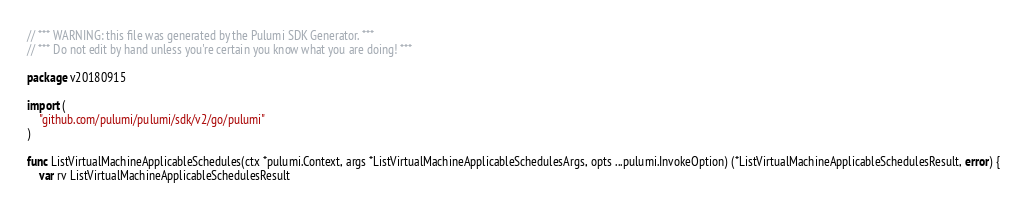<code> <loc_0><loc_0><loc_500><loc_500><_Go_>// *** WARNING: this file was generated by the Pulumi SDK Generator. ***
// *** Do not edit by hand unless you're certain you know what you are doing! ***

package v20180915

import (
	"github.com/pulumi/pulumi/sdk/v2/go/pulumi"
)

func ListVirtualMachineApplicableSchedules(ctx *pulumi.Context, args *ListVirtualMachineApplicableSchedulesArgs, opts ...pulumi.InvokeOption) (*ListVirtualMachineApplicableSchedulesResult, error) {
	var rv ListVirtualMachineApplicableSchedulesResult</code> 